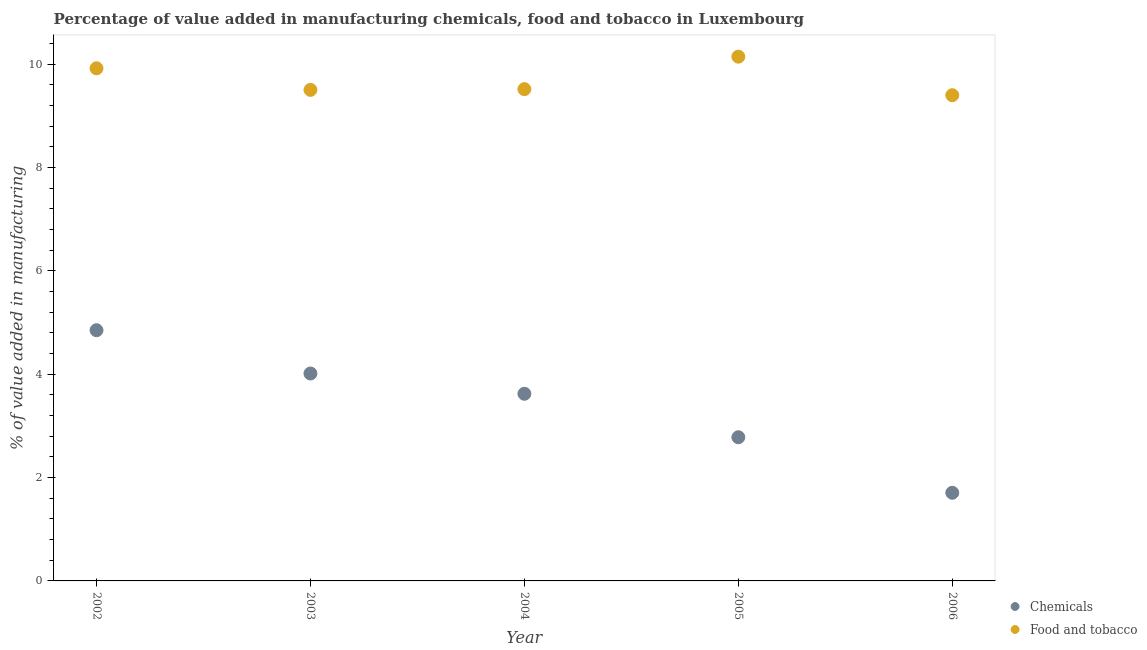What is the value added by manufacturing food and tobacco in 2006?
Keep it short and to the point. 9.4. Across all years, what is the maximum value added by manufacturing food and tobacco?
Offer a very short reply. 10.14. Across all years, what is the minimum value added by  manufacturing chemicals?
Offer a very short reply. 1.71. In which year was the value added by  manufacturing chemicals maximum?
Provide a succinct answer. 2002. What is the total value added by  manufacturing chemicals in the graph?
Your answer should be compact. 16.97. What is the difference between the value added by manufacturing food and tobacco in 2002 and that in 2005?
Your response must be concise. -0.22. What is the difference between the value added by  manufacturing chemicals in 2002 and the value added by manufacturing food and tobacco in 2004?
Provide a short and direct response. -4.66. What is the average value added by manufacturing food and tobacco per year?
Your answer should be very brief. 9.69. In the year 2004, what is the difference between the value added by manufacturing food and tobacco and value added by  manufacturing chemicals?
Your response must be concise. 5.89. In how many years, is the value added by manufacturing food and tobacco greater than 2 %?
Offer a terse response. 5. What is the ratio of the value added by  manufacturing chemicals in 2005 to that in 2006?
Your response must be concise. 1.63. Is the difference between the value added by manufacturing food and tobacco in 2002 and 2004 greater than the difference between the value added by  manufacturing chemicals in 2002 and 2004?
Keep it short and to the point. No. What is the difference between the highest and the second highest value added by manufacturing food and tobacco?
Keep it short and to the point. 0.22. What is the difference between the highest and the lowest value added by manufacturing food and tobacco?
Provide a short and direct response. 0.75. Is the sum of the value added by manufacturing food and tobacco in 2003 and 2004 greater than the maximum value added by  manufacturing chemicals across all years?
Provide a succinct answer. Yes. How many dotlines are there?
Your answer should be very brief. 2. How many years are there in the graph?
Your response must be concise. 5. What is the difference between two consecutive major ticks on the Y-axis?
Give a very brief answer. 2. Are the values on the major ticks of Y-axis written in scientific E-notation?
Provide a short and direct response. No. How many legend labels are there?
Make the answer very short. 2. How are the legend labels stacked?
Your response must be concise. Vertical. What is the title of the graph?
Offer a very short reply. Percentage of value added in manufacturing chemicals, food and tobacco in Luxembourg. What is the label or title of the Y-axis?
Your answer should be very brief. % of value added in manufacturing. What is the % of value added in manufacturing of Chemicals in 2002?
Ensure brevity in your answer.  4.85. What is the % of value added in manufacturing of Food and tobacco in 2002?
Your answer should be very brief. 9.92. What is the % of value added in manufacturing of Chemicals in 2003?
Offer a terse response. 4.01. What is the % of value added in manufacturing in Food and tobacco in 2003?
Ensure brevity in your answer.  9.5. What is the % of value added in manufacturing of Chemicals in 2004?
Keep it short and to the point. 3.62. What is the % of value added in manufacturing in Food and tobacco in 2004?
Your answer should be compact. 9.51. What is the % of value added in manufacturing of Chemicals in 2005?
Your answer should be compact. 2.78. What is the % of value added in manufacturing of Food and tobacco in 2005?
Provide a succinct answer. 10.14. What is the % of value added in manufacturing of Chemicals in 2006?
Keep it short and to the point. 1.71. What is the % of value added in manufacturing of Food and tobacco in 2006?
Give a very brief answer. 9.4. Across all years, what is the maximum % of value added in manufacturing in Chemicals?
Offer a very short reply. 4.85. Across all years, what is the maximum % of value added in manufacturing of Food and tobacco?
Offer a terse response. 10.14. Across all years, what is the minimum % of value added in manufacturing in Chemicals?
Offer a very short reply. 1.71. Across all years, what is the minimum % of value added in manufacturing of Food and tobacco?
Give a very brief answer. 9.4. What is the total % of value added in manufacturing in Chemicals in the graph?
Offer a very short reply. 16.97. What is the total % of value added in manufacturing in Food and tobacco in the graph?
Keep it short and to the point. 48.47. What is the difference between the % of value added in manufacturing in Chemicals in 2002 and that in 2003?
Keep it short and to the point. 0.84. What is the difference between the % of value added in manufacturing of Food and tobacco in 2002 and that in 2003?
Give a very brief answer. 0.42. What is the difference between the % of value added in manufacturing in Chemicals in 2002 and that in 2004?
Make the answer very short. 1.23. What is the difference between the % of value added in manufacturing in Food and tobacco in 2002 and that in 2004?
Your response must be concise. 0.4. What is the difference between the % of value added in manufacturing in Chemicals in 2002 and that in 2005?
Provide a short and direct response. 2.07. What is the difference between the % of value added in manufacturing in Food and tobacco in 2002 and that in 2005?
Make the answer very short. -0.22. What is the difference between the % of value added in manufacturing of Chemicals in 2002 and that in 2006?
Your response must be concise. 3.15. What is the difference between the % of value added in manufacturing of Food and tobacco in 2002 and that in 2006?
Provide a short and direct response. 0.52. What is the difference between the % of value added in manufacturing of Chemicals in 2003 and that in 2004?
Your answer should be compact. 0.39. What is the difference between the % of value added in manufacturing of Food and tobacco in 2003 and that in 2004?
Your answer should be compact. -0.01. What is the difference between the % of value added in manufacturing of Chemicals in 2003 and that in 2005?
Your response must be concise. 1.23. What is the difference between the % of value added in manufacturing of Food and tobacco in 2003 and that in 2005?
Offer a terse response. -0.64. What is the difference between the % of value added in manufacturing of Chemicals in 2003 and that in 2006?
Provide a succinct answer. 2.31. What is the difference between the % of value added in manufacturing in Food and tobacco in 2003 and that in 2006?
Your answer should be compact. 0.1. What is the difference between the % of value added in manufacturing of Chemicals in 2004 and that in 2005?
Offer a terse response. 0.84. What is the difference between the % of value added in manufacturing in Food and tobacco in 2004 and that in 2005?
Keep it short and to the point. -0.63. What is the difference between the % of value added in manufacturing in Chemicals in 2004 and that in 2006?
Ensure brevity in your answer.  1.92. What is the difference between the % of value added in manufacturing in Food and tobacco in 2004 and that in 2006?
Your response must be concise. 0.12. What is the difference between the % of value added in manufacturing of Chemicals in 2005 and that in 2006?
Your answer should be very brief. 1.07. What is the difference between the % of value added in manufacturing of Food and tobacco in 2005 and that in 2006?
Offer a very short reply. 0.75. What is the difference between the % of value added in manufacturing in Chemicals in 2002 and the % of value added in manufacturing in Food and tobacco in 2003?
Your response must be concise. -4.65. What is the difference between the % of value added in manufacturing in Chemicals in 2002 and the % of value added in manufacturing in Food and tobacco in 2004?
Offer a terse response. -4.66. What is the difference between the % of value added in manufacturing of Chemicals in 2002 and the % of value added in manufacturing of Food and tobacco in 2005?
Your answer should be very brief. -5.29. What is the difference between the % of value added in manufacturing of Chemicals in 2002 and the % of value added in manufacturing of Food and tobacco in 2006?
Your answer should be very brief. -4.55. What is the difference between the % of value added in manufacturing of Chemicals in 2003 and the % of value added in manufacturing of Food and tobacco in 2004?
Make the answer very short. -5.5. What is the difference between the % of value added in manufacturing in Chemicals in 2003 and the % of value added in manufacturing in Food and tobacco in 2005?
Provide a succinct answer. -6.13. What is the difference between the % of value added in manufacturing in Chemicals in 2003 and the % of value added in manufacturing in Food and tobacco in 2006?
Offer a terse response. -5.38. What is the difference between the % of value added in manufacturing in Chemicals in 2004 and the % of value added in manufacturing in Food and tobacco in 2005?
Ensure brevity in your answer.  -6.52. What is the difference between the % of value added in manufacturing of Chemicals in 2004 and the % of value added in manufacturing of Food and tobacco in 2006?
Your answer should be very brief. -5.78. What is the difference between the % of value added in manufacturing of Chemicals in 2005 and the % of value added in manufacturing of Food and tobacco in 2006?
Ensure brevity in your answer.  -6.62. What is the average % of value added in manufacturing in Chemicals per year?
Your answer should be compact. 3.39. What is the average % of value added in manufacturing of Food and tobacco per year?
Give a very brief answer. 9.69. In the year 2002, what is the difference between the % of value added in manufacturing of Chemicals and % of value added in manufacturing of Food and tobacco?
Provide a succinct answer. -5.07. In the year 2003, what is the difference between the % of value added in manufacturing of Chemicals and % of value added in manufacturing of Food and tobacco?
Offer a very short reply. -5.49. In the year 2004, what is the difference between the % of value added in manufacturing of Chemicals and % of value added in manufacturing of Food and tobacco?
Ensure brevity in your answer.  -5.89. In the year 2005, what is the difference between the % of value added in manufacturing of Chemicals and % of value added in manufacturing of Food and tobacco?
Your answer should be very brief. -7.36. In the year 2006, what is the difference between the % of value added in manufacturing in Chemicals and % of value added in manufacturing in Food and tobacco?
Your answer should be very brief. -7.69. What is the ratio of the % of value added in manufacturing in Chemicals in 2002 to that in 2003?
Keep it short and to the point. 1.21. What is the ratio of the % of value added in manufacturing of Food and tobacco in 2002 to that in 2003?
Your answer should be compact. 1.04. What is the ratio of the % of value added in manufacturing of Chemicals in 2002 to that in 2004?
Give a very brief answer. 1.34. What is the ratio of the % of value added in manufacturing of Food and tobacco in 2002 to that in 2004?
Give a very brief answer. 1.04. What is the ratio of the % of value added in manufacturing of Chemicals in 2002 to that in 2005?
Give a very brief answer. 1.74. What is the ratio of the % of value added in manufacturing in Food and tobacco in 2002 to that in 2005?
Give a very brief answer. 0.98. What is the ratio of the % of value added in manufacturing of Chemicals in 2002 to that in 2006?
Offer a very short reply. 2.84. What is the ratio of the % of value added in manufacturing of Food and tobacco in 2002 to that in 2006?
Ensure brevity in your answer.  1.06. What is the ratio of the % of value added in manufacturing of Chemicals in 2003 to that in 2004?
Offer a very short reply. 1.11. What is the ratio of the % of value added in manufacturing of Food and tobacco in 2003 to that in 2004?
Your answer should be very brief. 1. What is the ratio of the % of value added in manufacturing of Chemicals in 2003 to that in 2005?
Ensure brevity in your answer.  1.44. What is the ratio of the % of value added in manufacturing in Food and tobacco in 2003 to that in 2005?
Provide a succinct answer. 0.94. What is the ratio of the % of value added in manufacturing of Chemicals in 2003 to that in 2006?
Your answer should be compact. 2.35. What is the ratio of the % of value added in manufacturing of Food and tobacco in 2003 to that in 2006?
Keep it short and to the point. 1.01. What is the ratio of the % of value added in manufacturing in Chemicals in 2004 to that in 2005?
Offer a very short reply. 1.3. What is the ratio of the % of value added in manufacturing in Food and tobacco in 2004 to that in 2005?
Keep it short and to the point. 0.94. What is the ratio of the % of value added in manufacturing of Chemicals in 2004 to that in 2006?
Give a very brief answer. 2.12. What is the ratio of the % of value added in manufacturing in Food and tobacco in 2004 to that in 2006?
Make the answer very short. 1.01. What is the ratio of the % of value added in manufacturing of Chemicals in 2005 to that in 2006?
Your answer should be compact. 1.63. What is the ratio of the % of value added in manufacturing of Food and tobacco in 2005 to that in 2006?
Provide a succinct answer. 1.08. What is the difference between the highest and the second highest % of value added in manufacturing in Chemicals?
Provide a succinct answer. 0.84. What is the difference between the highest and the second highest % of value added in manufacturing in Food and tobacco?
Provide a short and direct response. 0.22. What is the difference between the highest and the lowest % of value added in manufacturing of Chemicals?
Offer a terse response. 3.15. What is the difference between the highest and the lowest % of value added in manufacturing of Food and tobacco?
Keep it short and to the point. 0.75. 